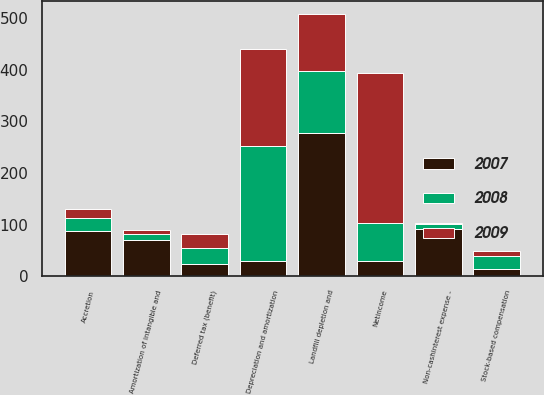Convert chart to OTSL. <chart><loc_0><loc_0><loc_500><loc_500><stacked_bar_chart><ecel><fcel>Netincome<fcel>Depreciation and amortization<fcel>Landfill depletion and<fcel>Amortization of intangible and<fcel>Accretion<fcel>Non-cashinterest expense -<fcel>Stock-based compensation<fcel>Deferred tax (benefit)<nl><fcel>2007<fcel>29.1<fcel>29.1<fcel>278.5<fcel>70.6<fcel>88.8<fcel>92.1<fcel>15<fcel>24.6<nl><fcel>2008<fcel>73.9<fcel>222.6<fcel>119.7<fcel>11.8<fcel>23.9<fcel>10.1<fcel>24<fcel>30.4<nl><fcel>2009<fcel>290.2<fcel>188.9<fcel>110.1<fcel>6.5<fcel>17.1<fcel>0.5<fcel>10.9<fcel>27.8<nl></chart> 